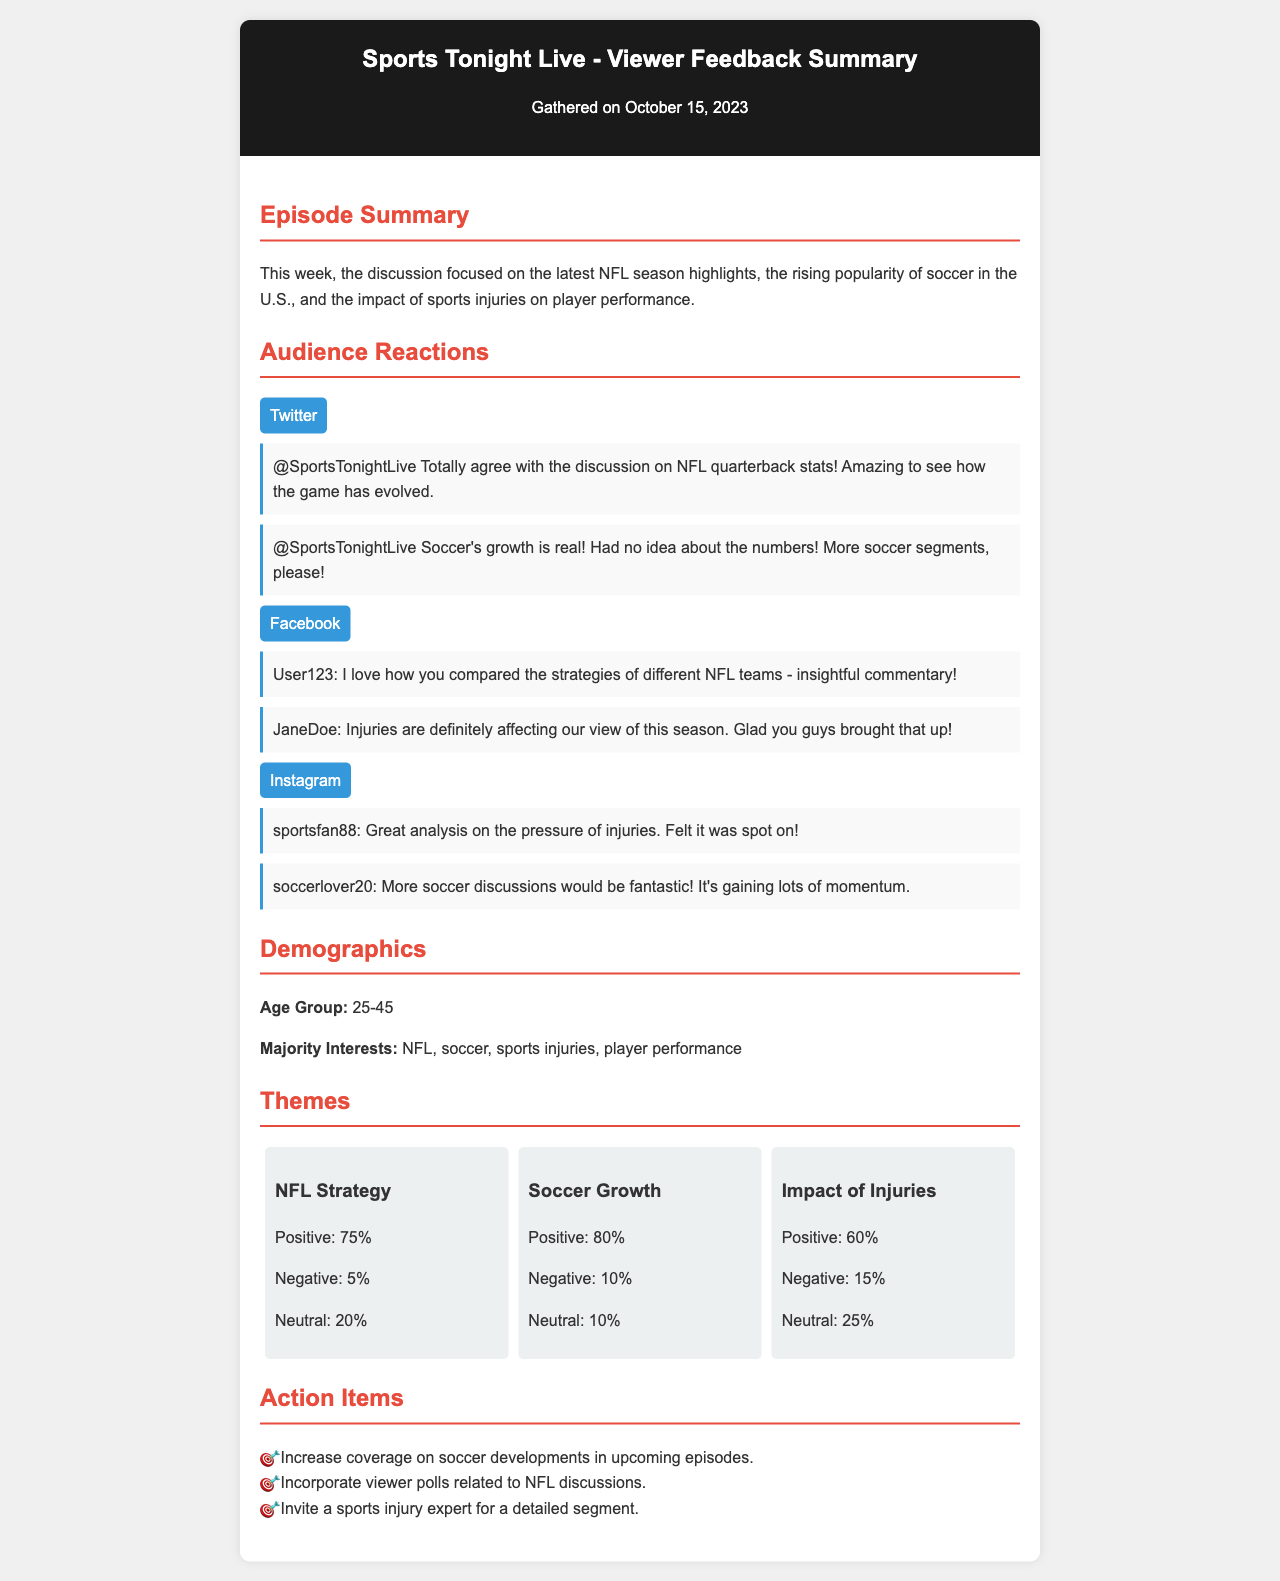What was the focus of this week's discussion? The focus of this week's discussion is summarized in the episode summary, highlighting NFL season highlights, soccer popularity, and sports injuries.
Answer: NFL season highlights, soccer popularity, and sports injuries What is the date of the viewer feedback summary? The date is mentioned at the top of the document, indicating when the feedback summary was gathered.
Answer: October 15, 2023 How many platforms provided audience reactions? The document mentions audience reactions from three distinct platforms.
Answer: Three What percentage of audience reactions about NFL Strategy were positive? The percentage is stated in the themes section under NFL Strategy.
Answer: 75% Which demographic is the majority age group of the audience? The majority age group is specified in the demographics section of the document.
Answer: 25-45 What action is recommended regarding soccer coverage? The action item suggests increasing a specific type of coverage based on viewer feedback.
Answer: Increase coverage on soccer developments What is the level of positive reactions regarding Soccer Growth? The positive reaction percentage for Soccer Growth is explicitly provided in the themes section.
Answer: 80% Who expressed a positive sentiment about injuries affecting the season? A specific user from Facebook shared a notable thought regarding the impact of injuries on the season.
Answer: JaneDoe 